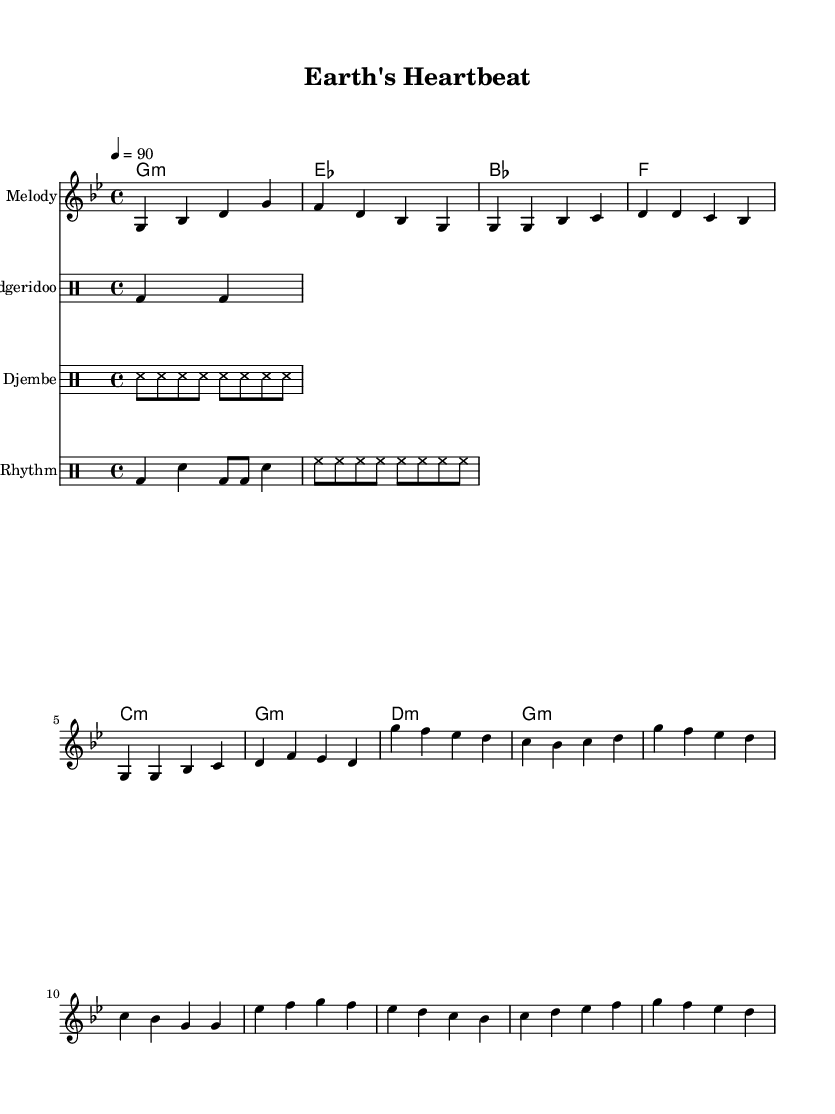What is the key signature of this music? The key signature is G minor, which has two flats (B♭ and E♭). This can be determined by looking at the key signature indicated at the beginning of the music.
Answer: G minor What is the time signature of this music? The time signature is 4/4, which indicates that there are four beats in each measure, and the quarter note gets one beat. This can be seen in the time signature notation at the beginning of the sheet music.
Answer: 4/4 What is the tempo marking? The tempo marking is 90 beats per minute, indicated at the beginning of the piece. This specifies how fast the music should be played.
Answer: 90 How many measures are in the melody? The melody consists of 12 measures, which can be counted by identifying the groups of four beats indicated in the staff. Each sequence from one bar line to the next represents one measure.
Answer: 12 What is the primary drum pattern used in the piece? The primary drum pattern includes a combination of the Didgeridoo and Djembe, with a pattern emphasizing bass and snare hits. This is inferred by observing the patterns designated for the drum instruments within the drum staffs.
Answer: Didgeridoo and Djembe What is the form of the piece? The form of the piece includes an intro, followed by verse sections and a chorus, indicating a typical song structure. By analyzing the labeled sections in the melody and the rhythmic patterns, one can discern this arrangement.
Answer: Intro, Verse, Chorus What traditional instrument is included in this piece? The Didgeridoo is a traditional instrument used in this piece, as specified in the drum staff labeled for it. This instrument is notable for its connection to indigenous cultures and adds an element of environmental wisdom to the hip-hop fusion.
Answer: Didgeridoo 